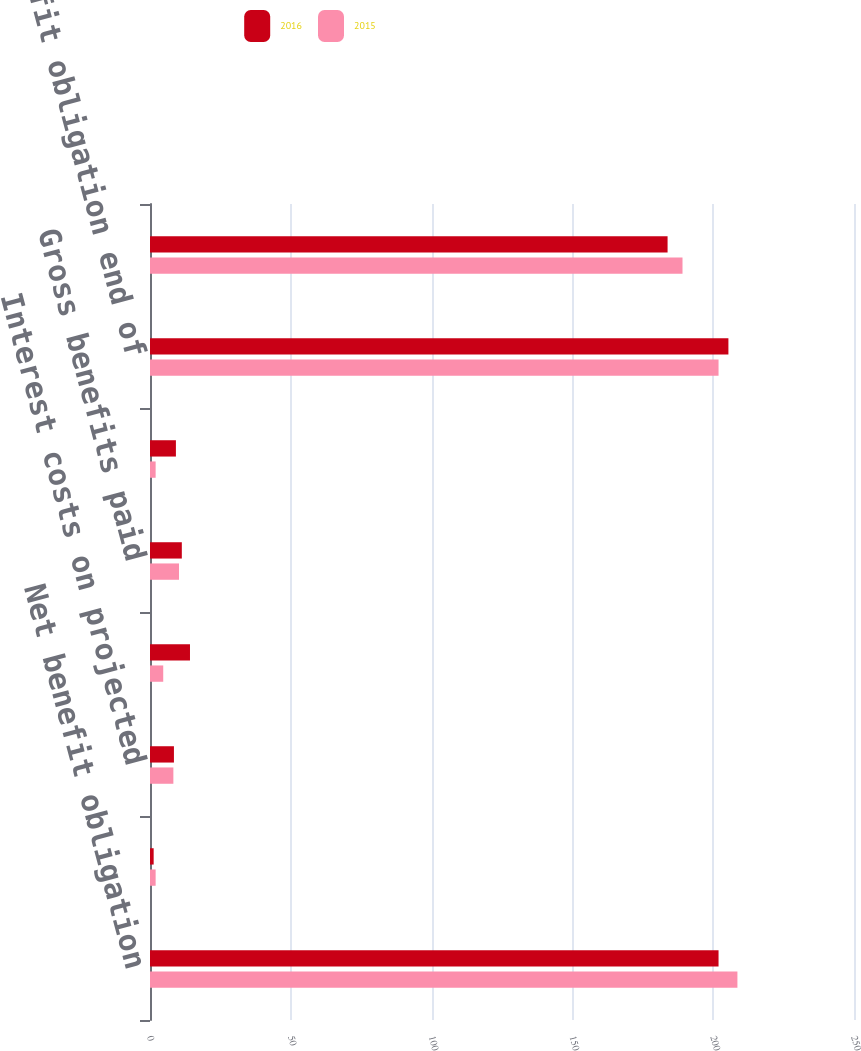Convert chart to OTSL. <chart><loc_0><loc_0><loc_500><loc_500><stacked_bar_chart><ecel><fcel>Net benefit obligation<fcel>Service costs incurred<fcel>Interest costs on projected<fcel>Actuarial loss (gain)<fcel>Gross benefits paid<fcel>Foreign currency exchange rate<fcel>Net benefit obligation end of<fcel>Fair value of plan assets<nl><fcel>2016<fcel>201.9<fcel>1.3<fcel>8.5<fcel>14.2<fcel>11.3<fcel>9.2<fcel>205.4<fcel>183.8<nl><fcel>2015<fcel>208.6<fcel>2<fcel>8.3<fcel>4.7<fcel>10.3<fcel>2<fcel>201.9<fcel>189.1<nl></chart> 